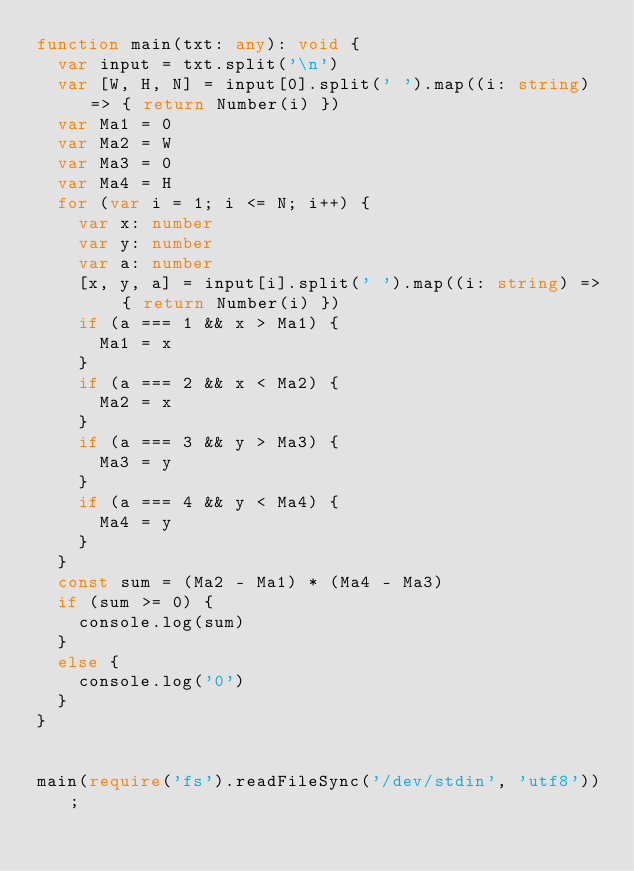Convert code to text. <code><loc_0><loc_0><loc_500><loc_500><_TypeScript_>function main(txt: any): void {
  var input = txt.split('\n')
  var [W, H, N] = input[0].split(' ').map((i: string) => { return Number(i) })
  var Ma1 = 0
  var Ma2 = W
  var Ma3 = 0
  var Ma4 = H
  for (var i = 1; i <= N; i++) {
    var x: number
    var y: number
    var a: number
    [x, y, a] = input[i].split(' ').map((i: string) => { return Number(i) })
    if (a === 1 && x > Ma1) {
      Ma1 = x
    }
    if (a === 2 && x < Ma2) {
      Ma2 = x
    }
    if (a === 3 && y > Ma3) {
      Ma3 = y
    }
    if (a === 4 && y < Ma4) {
      Ma4 = y
    }
  }
  const sum = (Ma2 - Ma1) * (Ma4 - Ma3)
  if (sum >= 0) {
    console.log(sum)
  }
  else {
    console.log('0')
  }
}


main(require('fs').readFileSync('/dev/stdin', 'utf8'));</code> 